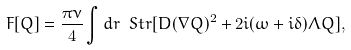<formula> <loc_0><loc_0><loc_500><loc_500>F [ Q ] = \frac { \pi \nu } { 4 } \int d r \ S t r [ D ( \nabla Q ) ^ { 2 } + 2 i ( \omega + i \delta ) \Lambda Q ] ,</formula> 